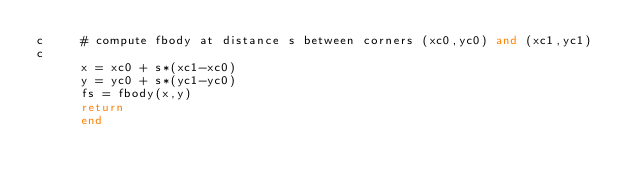<code> <loc_0><loc_0><loc_500><loc_500><_FORTRAN_>c     # compute fbody at distance s between corners (xc0,yc0) and (xc1,yc1)
c
      x = xc0 + s*(xc1-xc0)
      y = yc0 + s*(yc1-yc0)
      fs = fbody(x,y)
      return
      end
</code> 